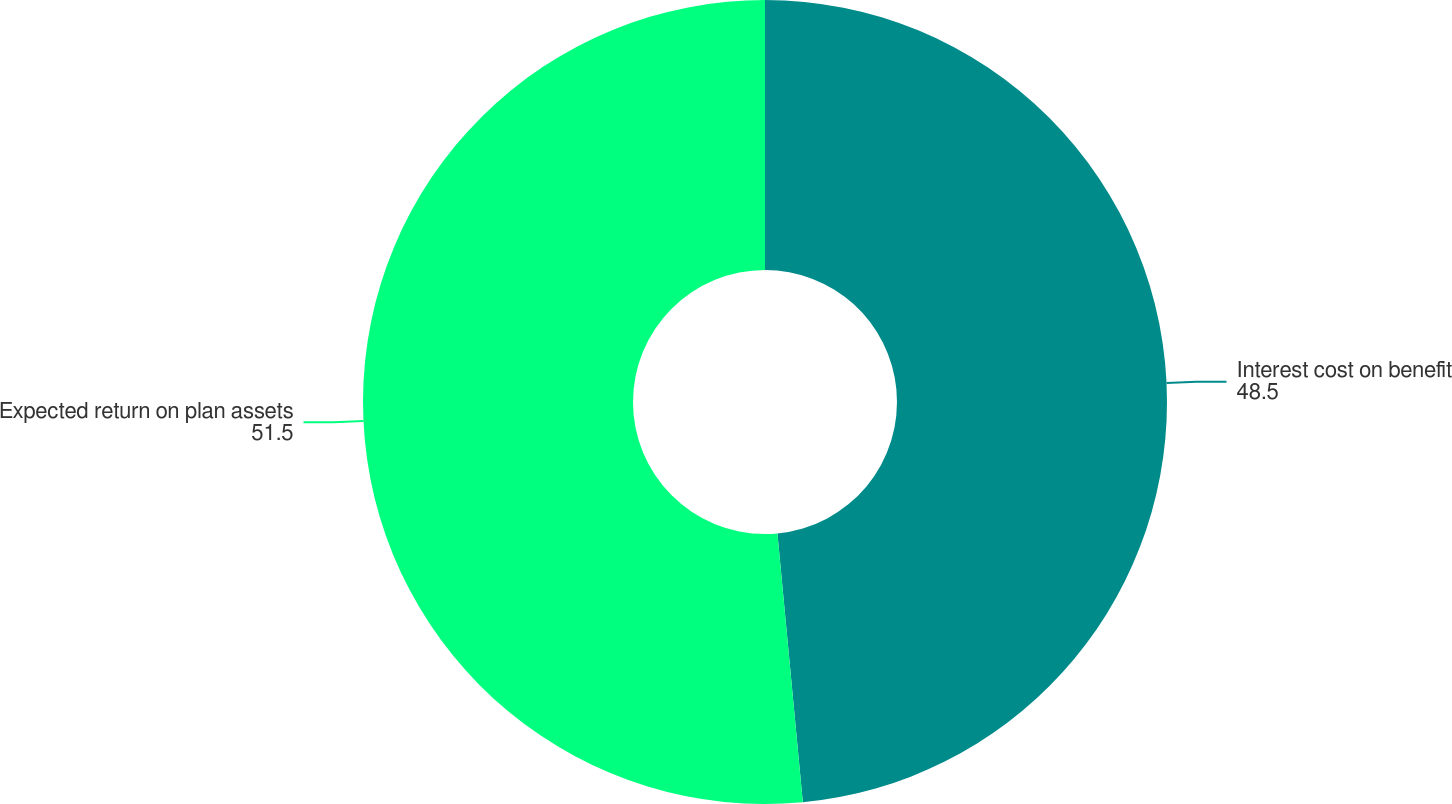Convert chart to OTSL. <chart><loc_0><loc_0><loc_500><loc_500><pie_chart><fcel>Interest cost on benefit<fcel>Expected return on plan assets<nl><fcel>48.5%<fcel>51.5%<nl></chart> 